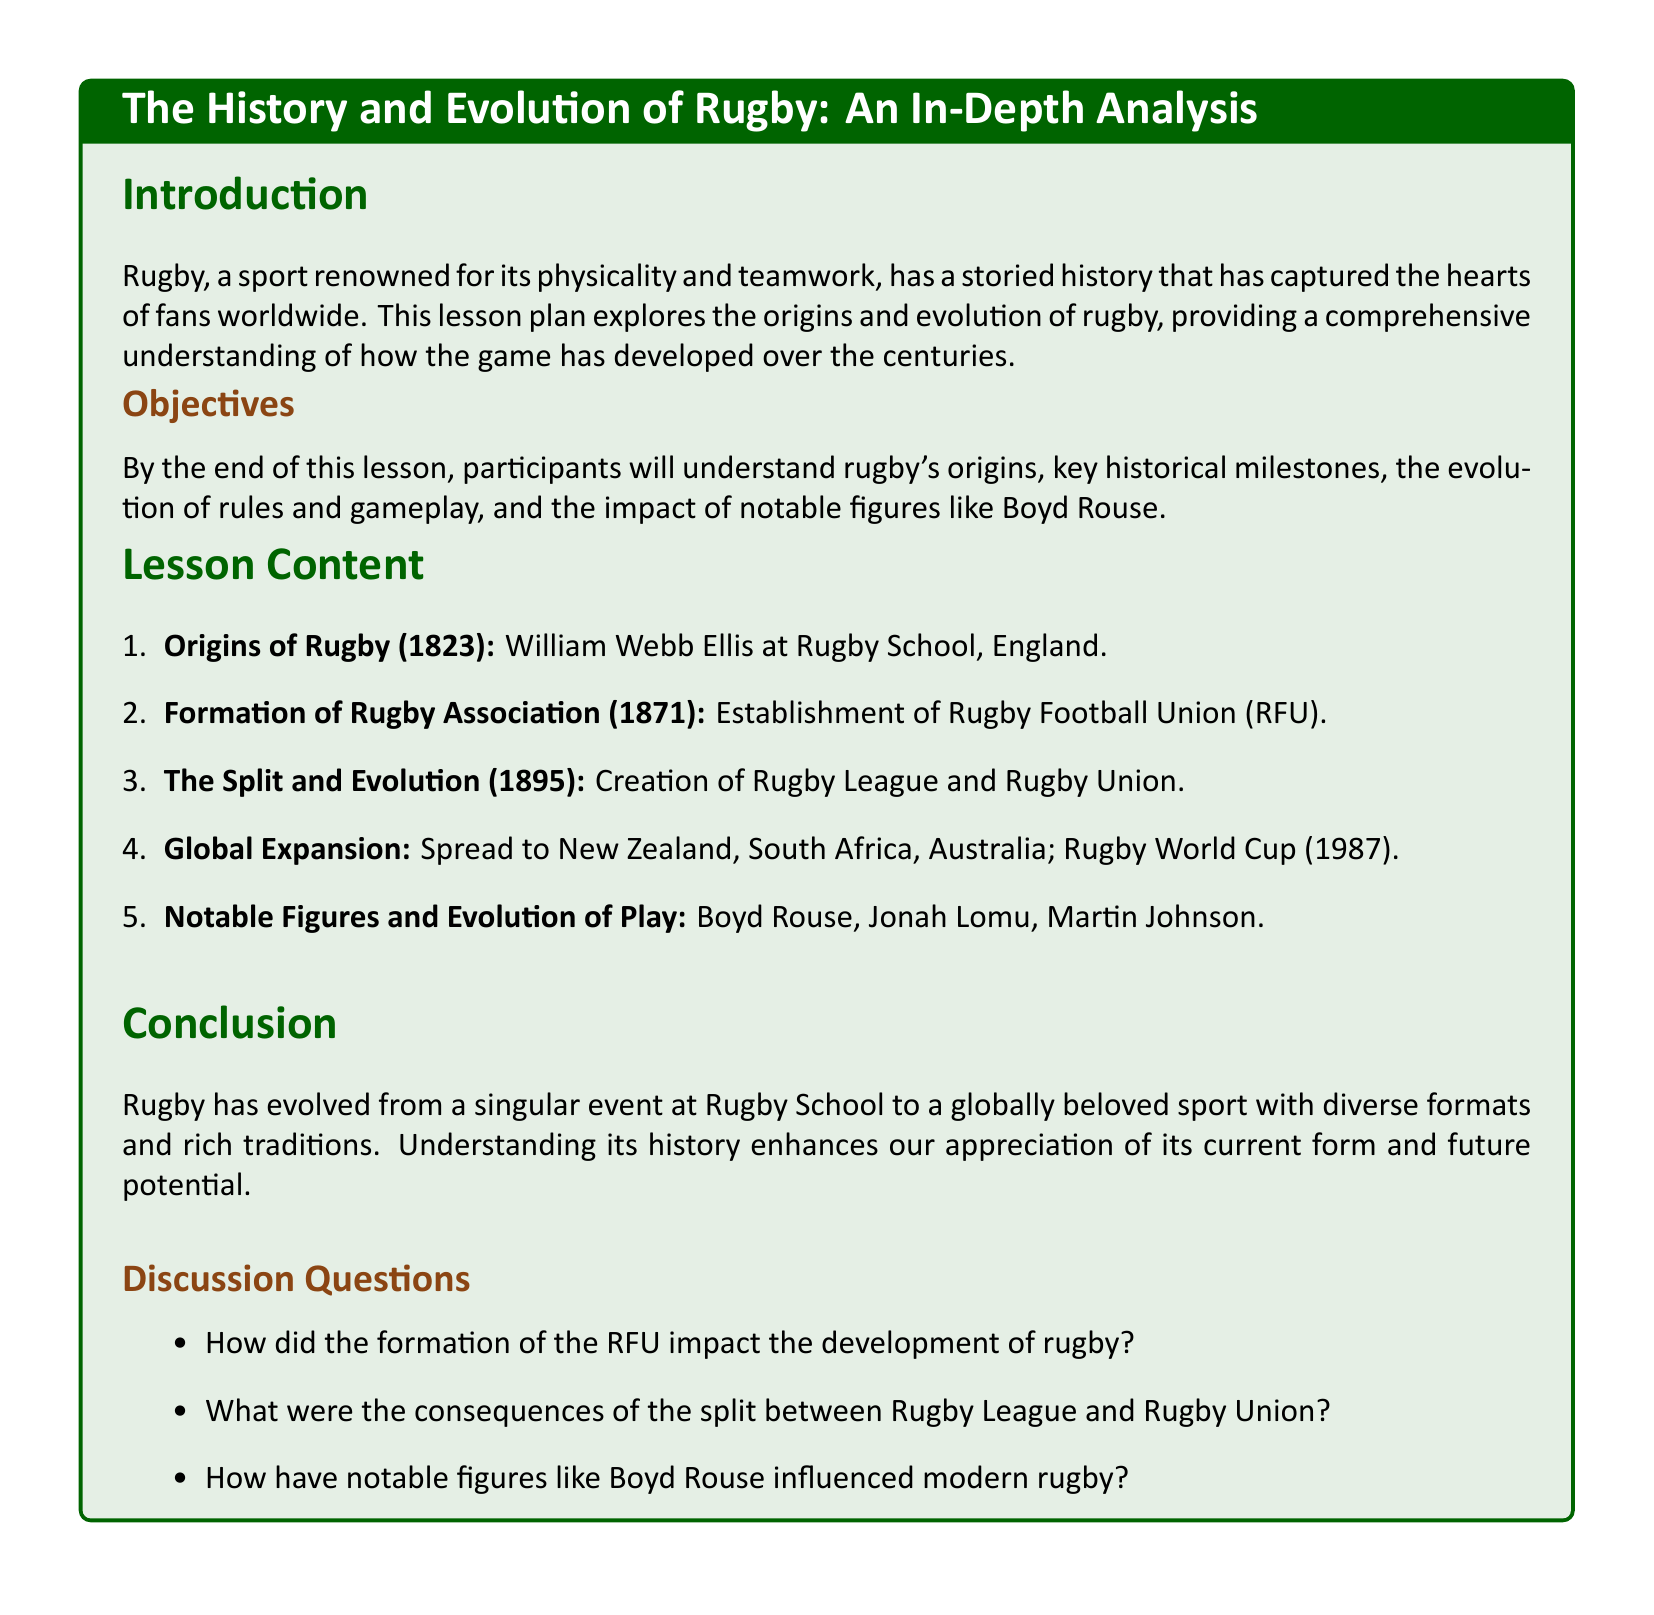What year did William Webb Ellis reportedly create rugby? The document states that rugby originated in 1823, attributed to William Webb Ellis.
Answer: 1823 What organization was formed in 1871? The lesson plan mentions the establishment of the Rugby Football Union (RFU) in 1871.
Answer: Rugby Football Union (RFU) What significant split occurred in 1895? The document notes the creation of Rugby League and Rugby Union as the significant split in 1895.
Answer: Rugby League and Rugby Union What event marked the global expansion of rugby in 1987? The Rugby World Cup is mentioned as a key event in the global expansion of rugby in 1987.
Answer: Rugby World Cup Who is recognized as a notable figure in rugby's evolution alongside Boyd Rouse? The lesson plan lists Jonah Lomu as another notable figure in rugby's evolution.
Answer: Jonah Lomu What is one of the objectives of the lesson? It aims to provide an understanding of rugby's origins as one of its objectives.
Answer: Understanding rugby's origins How does the lesson plan suggest notable figures influenced rugby? The discussion questions indicate that the impact of notable figures like Boyd Rouse on modern rugby is a focus of the lesson.
Answer: Influenced modern rugby What color is associated with the title of the lesson plan? The title format indicates that rugby green is the color used for the lesson title.
Answer: Rugby green 